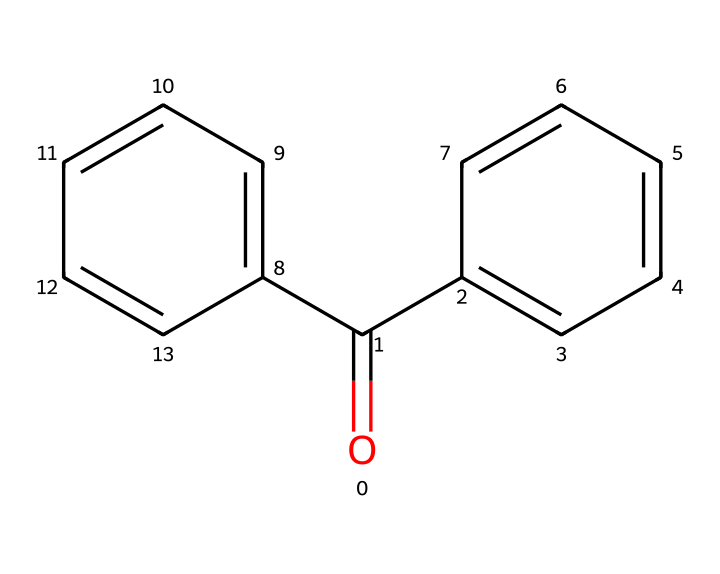What is the molecular formula of benzophenone? To derive the molecular formula from the SMILES, count each type of atom represented in the structure: there are 13 carbon atoms (c), 10 hydrogen atoms (h), and 1 oxygen atom (O). Hence, the molecular formula is C13H10O.
Answer: C13H10O How many ketone functional groups are present in benzophenone? By examining the structure, we see that there is a carbonyl group (C=O) attached to two aromatic rings, which is characteristic of a ketone. This structure indicates that there is one ketone functional group.
Answer: 1 What type of solvent would benzophenone most likely dissolve in? Benzophenone, being a non-polar compound due to its aromatic structure and presence of carbon chains, would likely dissolve in non-polar solvents like hexane rather than polar solvents like water.
Answer: non-polar solvents What physical property is affected by the conjugated system in benzophenone? The presence of a conjugated system (alternating double bonds in the aromatic rings) affects the color and UV absorption characteristics of benzophenone, making it effective in UV-cured applications. This is due to the electronic transitions facilitated by the conjugation.
Answer: UV absorption Why is benzophenone useful in UV-curing applications? Benzophenone contains a carbonyl group that can absorb UV light, leading to a photochemical reaction that generates free radicals essential for curing processes. The stability of the aromatic rings also helps maintain the material integrity after curing.
Answer: UV light absorption How many aromatic rings are present in benzophenone? By analyzing the structure, we can see there are two distinct benzene rings attached to the central carbonyl, indicating the presence of two aromatic rings.
Answer: 2 What is the role of the ketone functional group in the reactivity of benzophenone? The carbonyl (C=O) in the ketone functional group is pivotal for its ability to undergo chemical reactions, specifically in absorbing UV light which leads to the production of reactive species during curing, thus affecting its reactivity.
Answer: reactivity in UV curing 